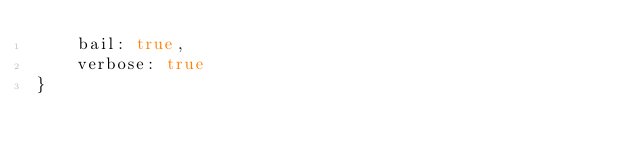Convert code to text. <code><loc_0><loc_0><loc_500><loc_500><_JavaScript_>    bail: true,
    verbose: true
}
</code> 